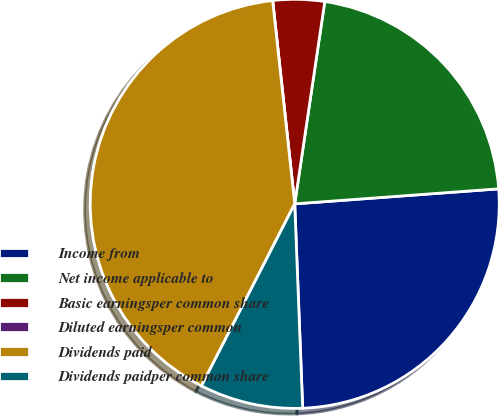Convert chart to OTSL. <chart><loc_0><loc_0><loc_500><loc_500><pie_chart><fcel>Income from<fcel>Net income applicable to<fcel>Basic earningsper common share<fcel>Diluted earningsper common<fcel>Dividends paid<fcel>Dividends paidper common share<nl><fcel>25.55%<fcel>21.48%<fcel>4.07%<fcel>0.0%<fcel>40.74%<fcel>8.15%<nl></chart> 